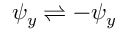Convert formula to latex. <formula><loc_0><loc_0><loc_500><loc_500>{ \psi _ { y } \rightleftharpoons - \psi _ { y } }</formula> 